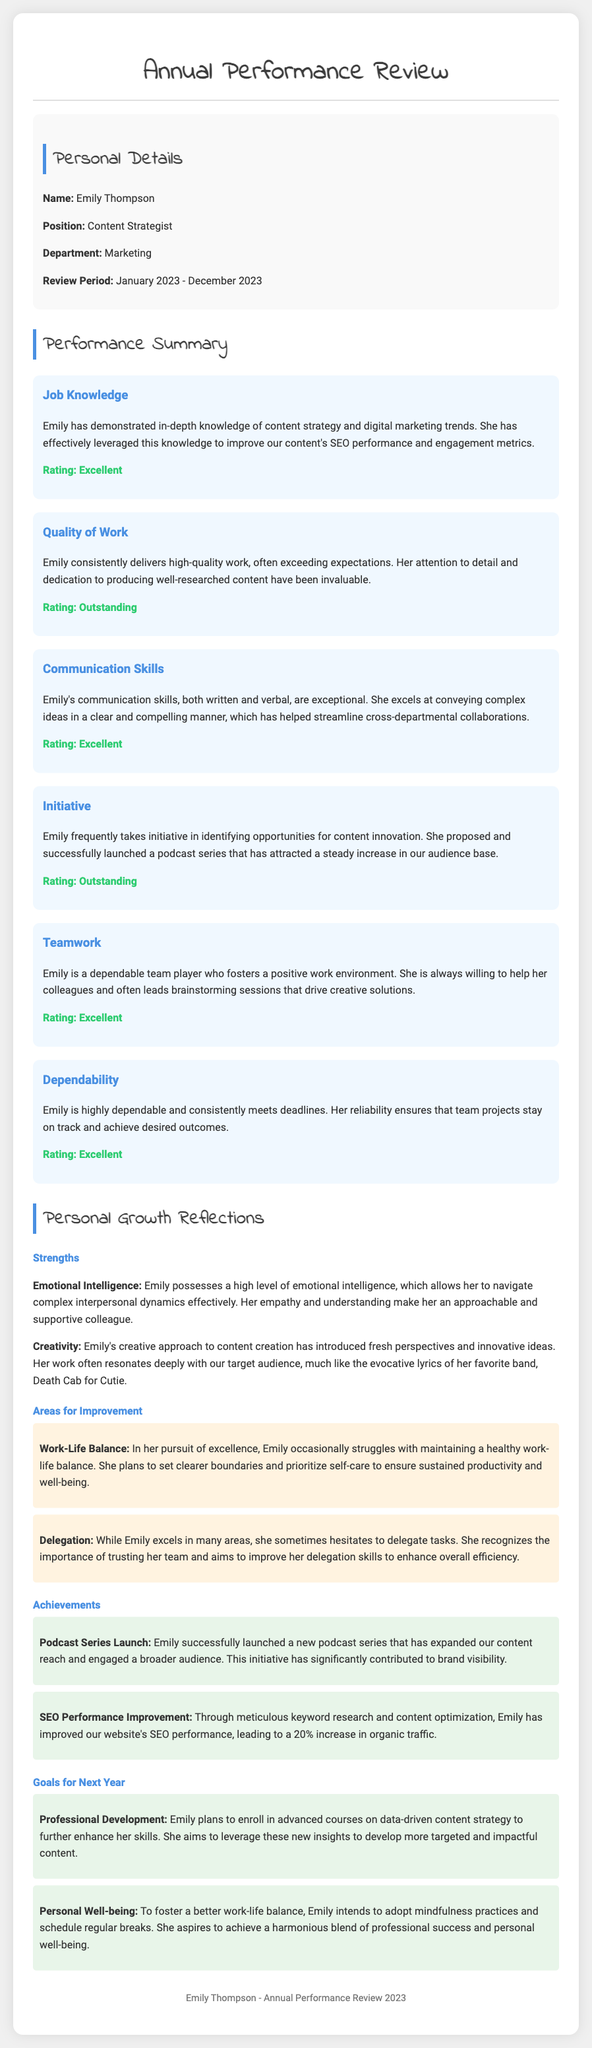what is the name of the employee? The employee's name is stated in the personal details section of the document.
Answer: Emily Thompson what is Emily's position? The position is mentioned in the personal details and tells us Emily's role at the company.
Answer: Content Strategist what is the review period? This is the timeframe for which Emily's performance is being evaluated, found in the personal details section.
Answer: January 2023 - December 2023 how was Emily rated for quality of work? The quality of work rating is provided in the performance summary section.
Answer: Outstanding what achievement is highlighted in the personal growth reflections? The achievements are listed in the reflections section, showcasing significant contributions made by Emily.
Answer: Podcast Series Launch what area does Emily want to improve in? Emily's areas for improvement are mentioned in the reflections, indicating her self-assessment.
Answer: Work-Life Balance how does Emily plan to enhance her professional skills? The goal for professional development involves specific learning plans mentioned in the goals section.
Answer: Advanced courses on data-driven content strategy what is one of Emily's strengths? Emily's strengths are assessed in the reflections, showcasing her positive attributes.
Answer: Emotional Intelligence what rating did Emily receive for dependability? Ratings are summarized systematically in the performance assessment part of the document.
Answer: Excellent 